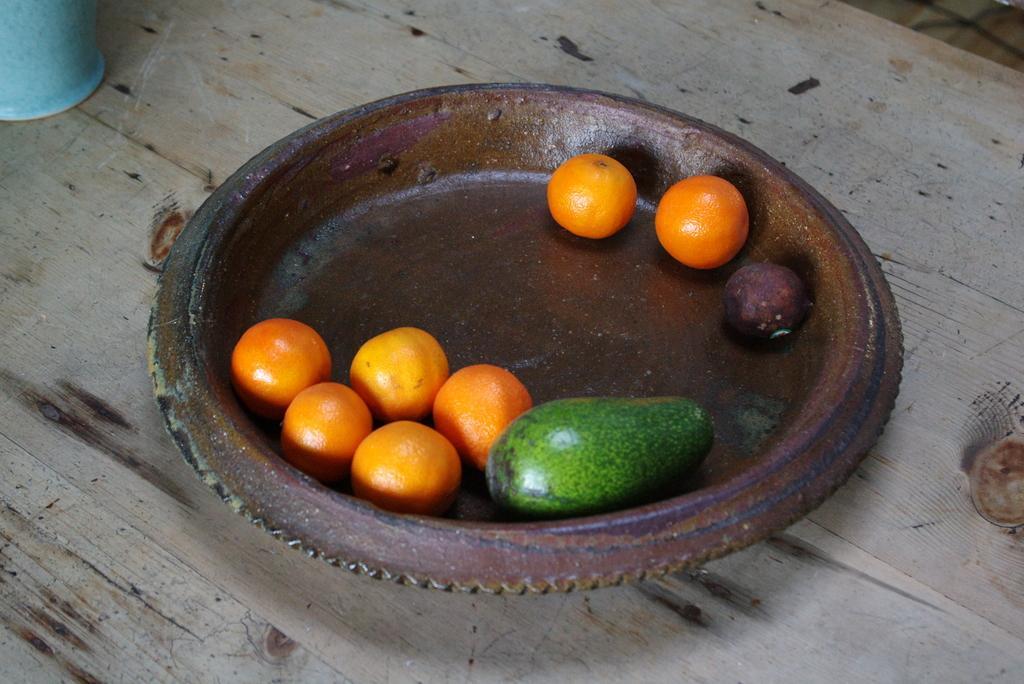How would you summarize this image in a sentence or two? We can see oranges and fruits in a plate and glass on table. 